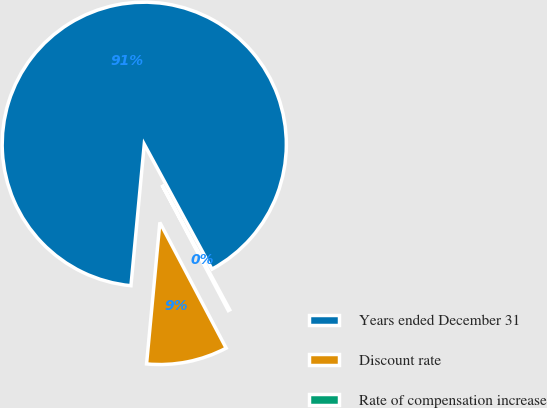Convert chart. <chart><loc_0><loc_0><loc_500><loc_500><pie_chart><fcel>Years ended December 31<fcel>Discount rate<fcel>Rate of compensation increase<nl><fcel>90.6%<fcel>9.22%<fcel>0.18%<nl></chart> 